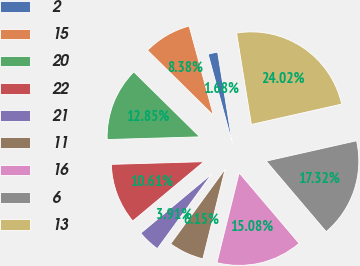<chart> <loc_0><loc_0><loc_500><loc_500><pie_chart><fcel>2<fcel>15<fcel>20<fcel>22<fcel>21<fcel>11<fcel>16<fcel>6<fcel>13<nl><fcel>1.68%<fcel>8.38%<fcel>12.85%<fcel>10.61%<fcel>3.91%<fcel>6.15%<fcel>15.08%<fcel>17.32%<fcel>24.02%<nl></chart> 